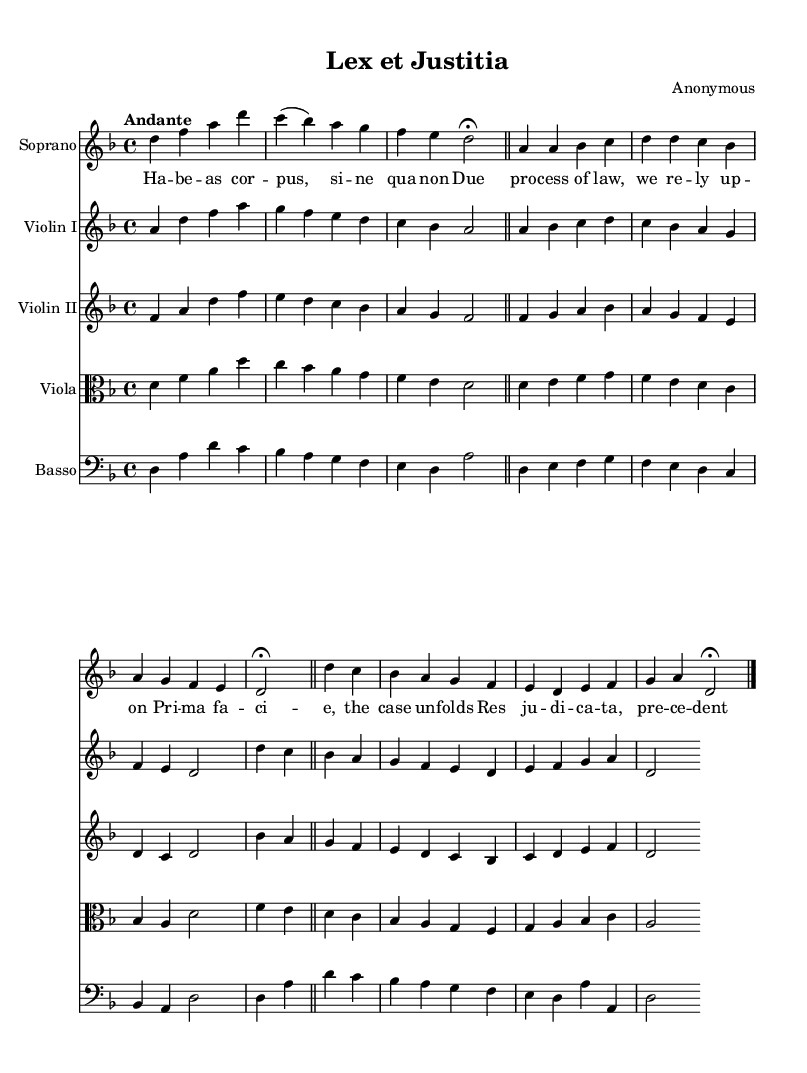What is the key signature of this music? The key signature is two flat notes, which indicates that the piece is in D minor. According to Western music theory, the presence of two flat symbols (B♭ and E♭) indicates D minor as the key signature.
Answer: D minor What is the time signature of this music? The time signature is indicated at the beginning of the score as 4/4. This means there are four beats in each measure, and the quarter note gets one beat. It is a standard time signature commonly used in Baroque music.
Answer: 4/4 What is the tempo marking for this music? The tempo marking is "Andante,” which refers to a moderately slow tempo, often equated to about 76 to 108 beats per minute. The term "Andante" commonly indicates that the music should flow in a calm and steady manner.
Answer: Andante How many distinct sections does the piece have? The piece includes three distinct sections: an aria, a recitative, and another aria. These are common structural components in a Baroque cantata where the aria is typically lyrical and expressive, and the recitative is more speech-like.
Answer: Three What is the function of the basso continuo in this piece? The basso continuo serves as the harmonic foundation and is characterized by the continuous bass line that supports the melodic lines above it. The cello, lute, or keyboard instruments typically play this part, providing chordal support in a Baroque setting.
Answer: Harmonic foundation Which legal principle is referenced in the lyrics? The lyrics refer to "Due process of law," a core legal principle that ensures fair treatment through the judicial system. It emphasizes that the government must respect all legal rights owed to a person, underscoring a fundamental aspect of legal proceedings.
Answer: Due process of law 